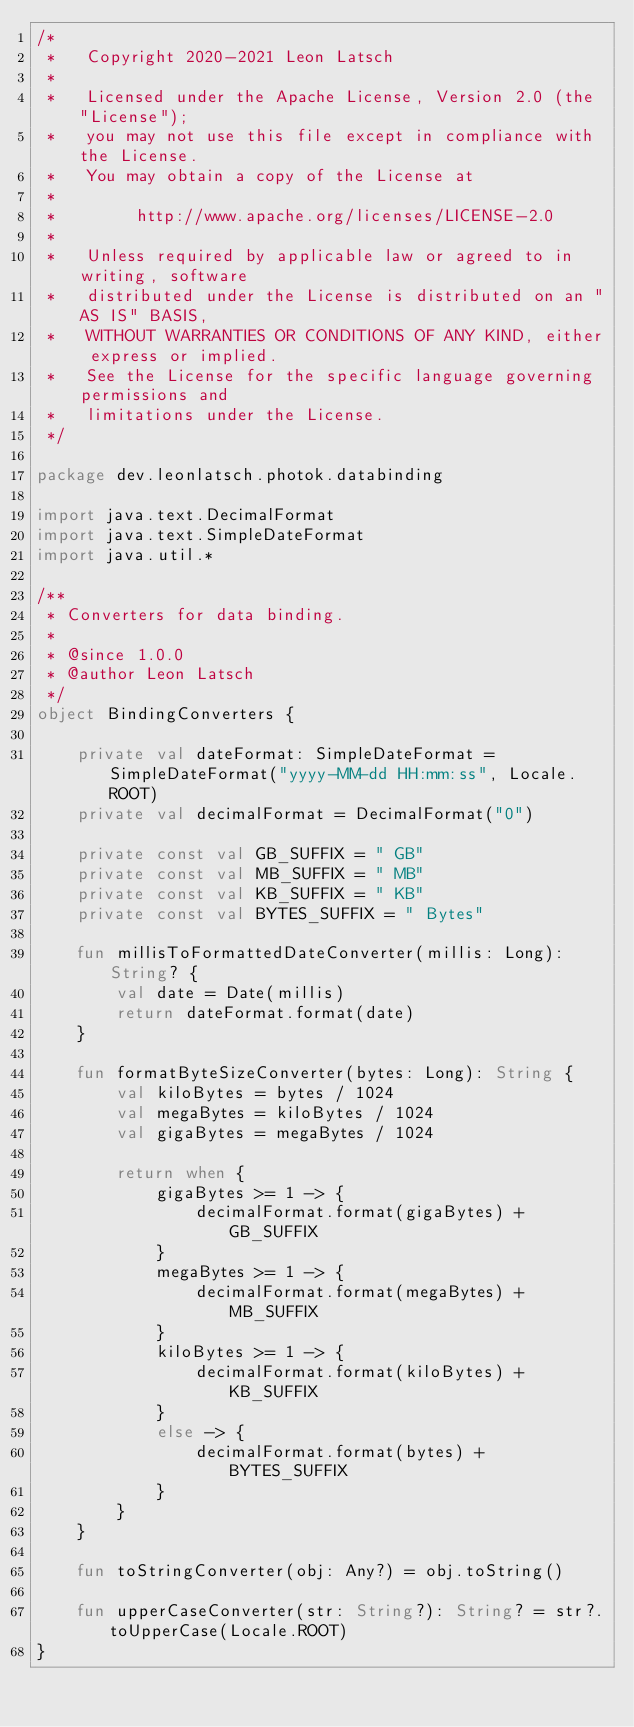<code> <loc_0><loc_0><loc_500><loc_500><_Kotlin_>/*
 *   Copyright 2020-2021 Leon Latsch
 *
 *   Licensed under the Apache License, Version 2.0 (the "License");
 *   you may not use this file except in compliance with the License.
 *   You may obtain a copy of the License at
 *
 *        http://www.apache.org/licenses/LICENSE-2.0
 *
 *   Unless required by applicable law or agreed to in writing, software
 *   distributed under the License is distributed on an "AS IS" BASIS,
 *   WITHOUT WARRANTIES OR CONDITIONS OF ANY KIND, either express or implied.
 *   See the License for the specific language governing permissions and
 *   limitations under the License.
 */

package dev.leonlatsch.photok.databinding

import java.text.DecimalFormat
import java.text.SimpleDateFormat
import java.util.*

/**
 * Converters for data binding.
 *
 * @since 1.0.0
 * @author Leon Latsch
 */
object BindingConverters {

    private val dateFormat: SimpleDateFormat = SimpleDateFormat("yyyy-MM-dd HH:mm:ss", Locale.ROOT)
    private val decimalFormat = DecimalFormat("0")

    private const val GB_SUFFIX = " GB"
    private const val MB_SUFFIX = " MB"
    private const val KB_SUFFIX = " KB"
    private const val BYTES_SUFFIX = " Bytes"

    fun millisToFormattedDateConverter(millis: Long): String? {
        val date = Date(millis)
        return dateFormat.format(date)
    }

    fun formatByteSizeConverter(bytes: Long): String {
        val kiloBytes = bytes / 1024
        val megaBytes = kiloBytes / 1024
        val gigaBytes = megaBytes / 1024

        return when {
            gigaBytes >= 1 -> {
                decimalFormat.format(gigaBytes) + GB_SUFFIX
            }
            megaBytes >= 1 -> {
                decimalFormat.format(megaBytes) + MB_SUFFIX
            }
            kiloBytes >= 1 -> {
                decimalFormat.format(kiloBytes) + KB_SUFFIX
            }
            else -> {
                decimalFormat.format(bytes) + BYTES_SUFFIX
            }
        }
    }

    fun toStringConverter(obj: Any?) = obj.toString()

    fun upperCaseConverter(str: String?): String? = str?.toUpperCase(Locale.ROOT)
}</code> 